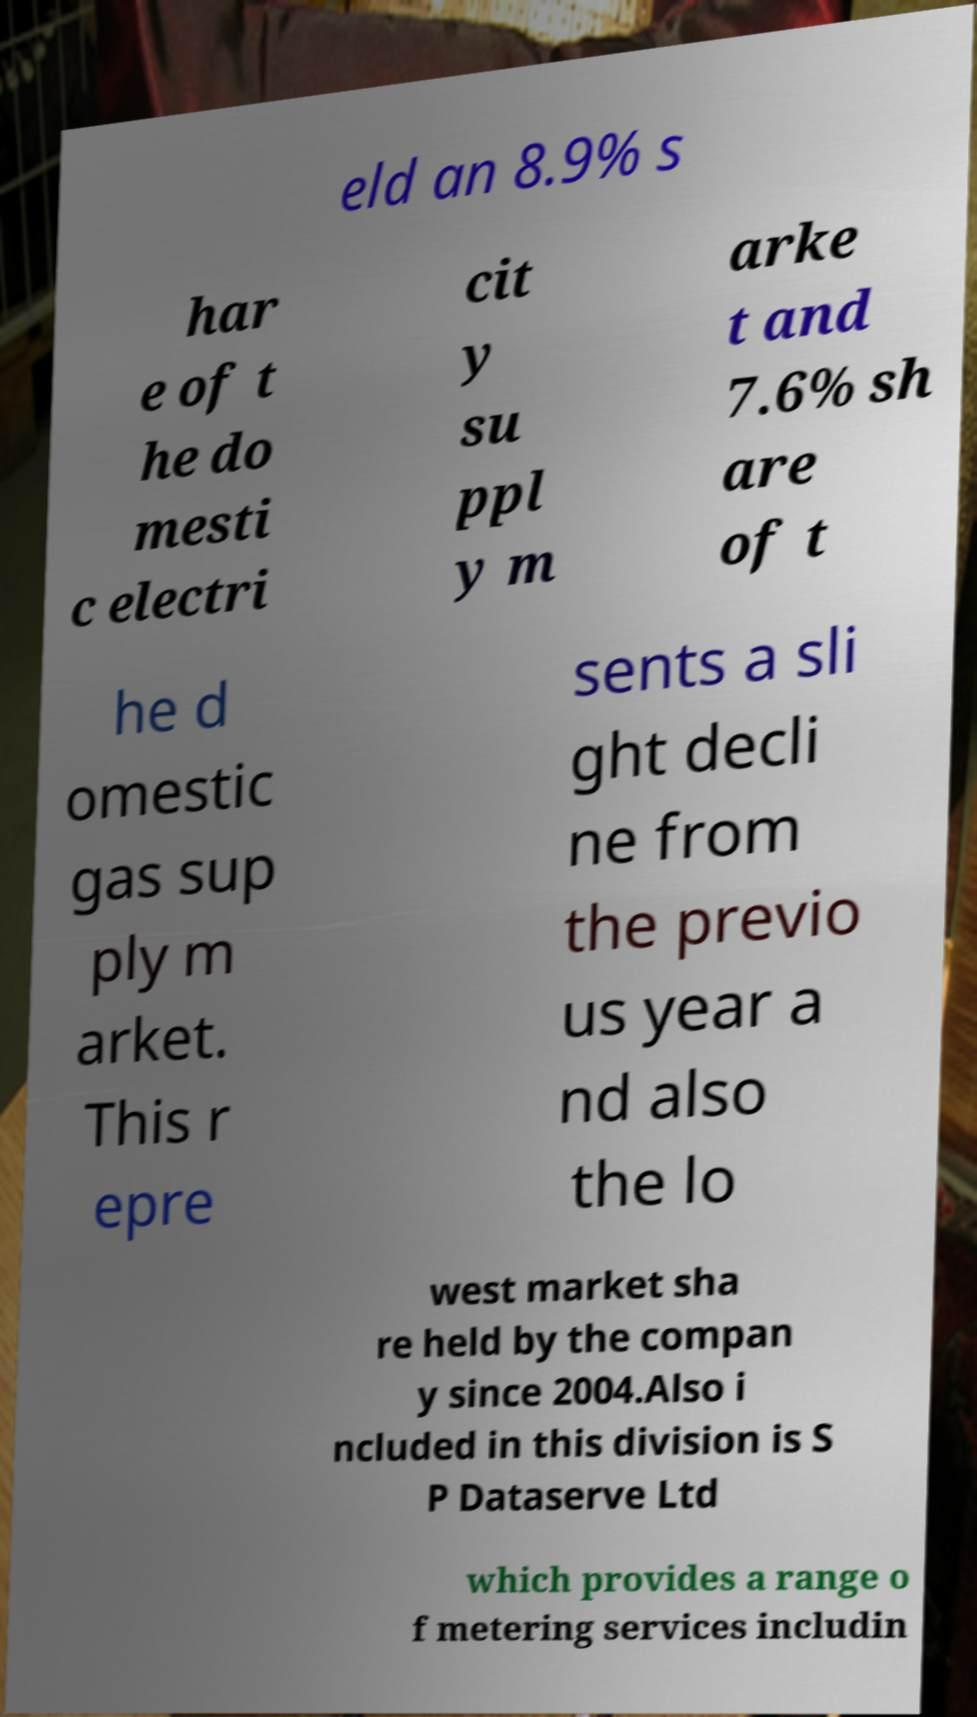Can you accurately transcribe the text from the provided image for me? eld an 8.9% s har e of t he do mesti c electri cit y su ppl y m arke t and 7.6% sh are of t he d omestic gas sup ply m arket. This r epre sents a sli ght decli ne from the previo us year a nd also the lo west market sha re held by the compan y since 2004.Also i ncluded in this division is S P Dataserve Ltd which provides a range o f metering services includin 